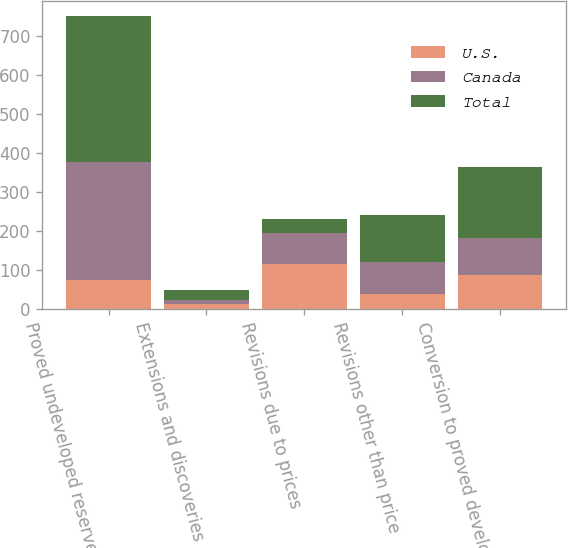Convert chart. <chart><loc_0><loc_0><loc_500><loc_500><stacked_bar_chart><ecel><fcel>Proved undeveloped reserves as<fcel>Extensions and discoveries<fcel>Revisions due to prices<fcel>Revisions other than price<fcel>Conversion to proved developed<nl><fcel>U.S.<fcel>75<fcel>13<fcel>115<fcel>40<fcel>88<nl><fcel>Canada<fcel>301<fcel>11<fcel>80<fcel>80<fcel>94<nl><fcel>Total<fcel>376<fcel>24<fcel>35<fcel>120<fcel>182<nl></chart> 